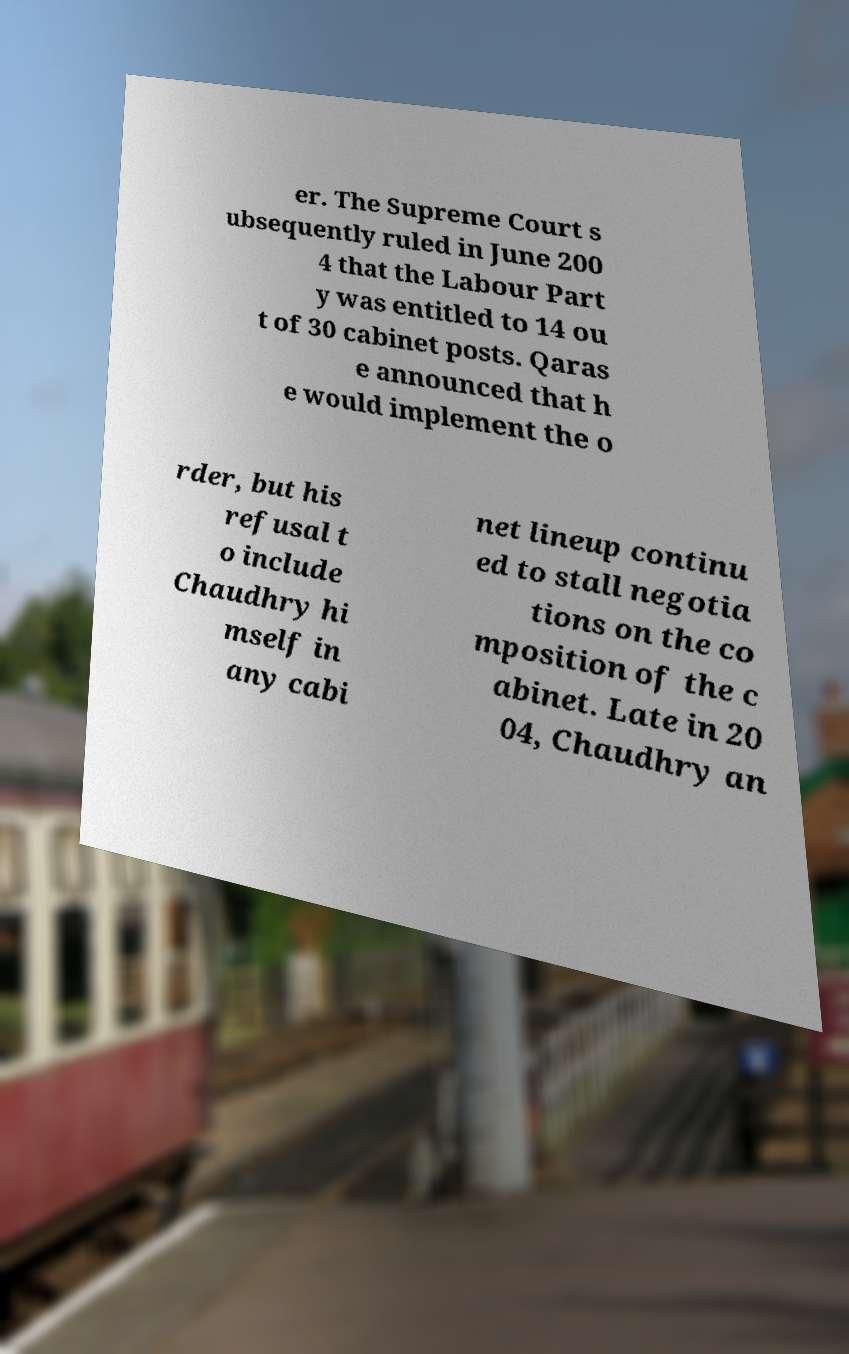I need the written content from this picture converted into text. Can you do that? er. The Supreme Court s ubsequently ruled in June 200 4 that the Labour Part y was entitled to 14 ou t of 30 cabinet posts. Qaras e announced that h e would implement the o rder, but his refusal t o include Chaudhry hi mself in any cabi net lineup continu ed to stall negotia tions on the co mposition of the c abinet. Late in 20 04, Chaudhry an 